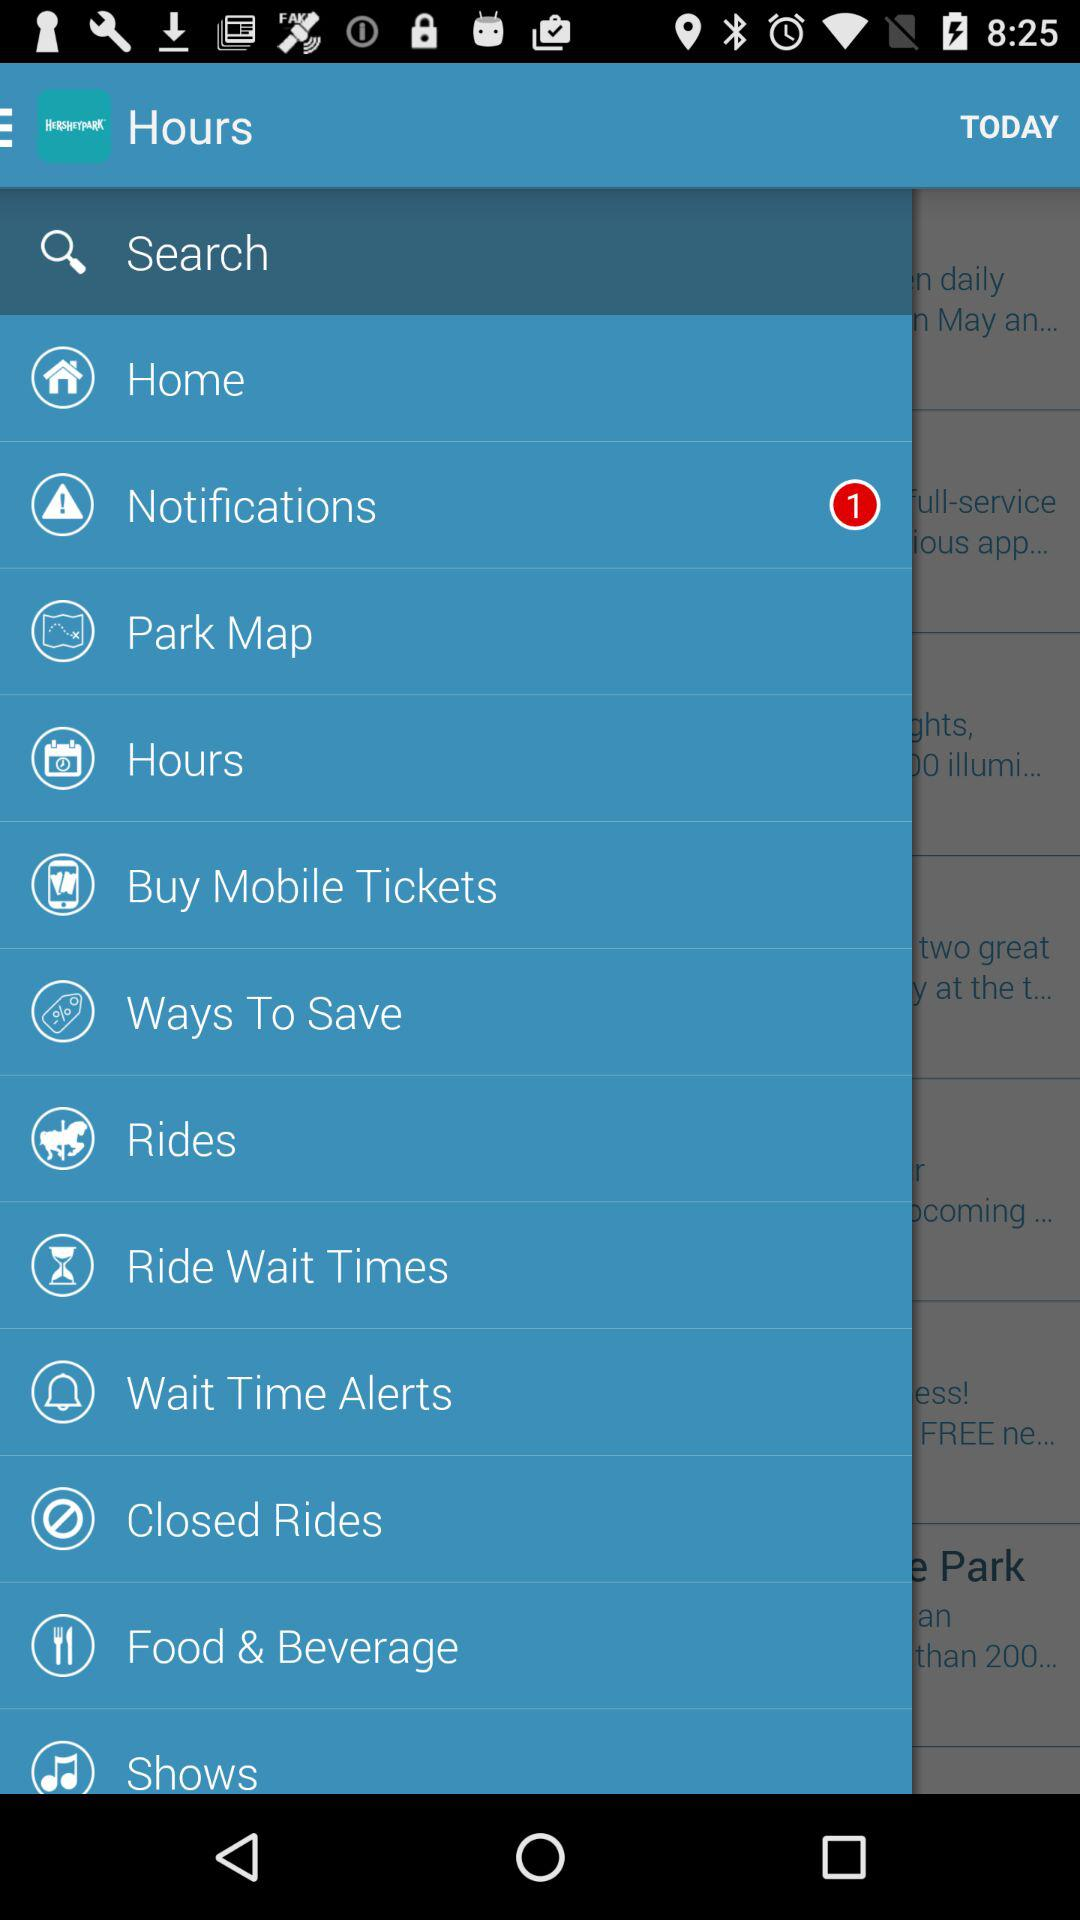Which item has been selected in the menu? The item that has been selected is "Search". 